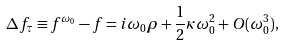Convert formula to latex. <formula><loc_0><loc_0><loc_500><loc_500>\Delta f _ { \tau } \equiv f ^ { \omega _ { 0 } } - f = i \omega _ { 0 } \rho + \frac { 1 } { 2 } \kappa \omega _ { 0 } ^ { 2 } + O ( \omega _ { 0 } ^ { 3 } ) ,</formula> 